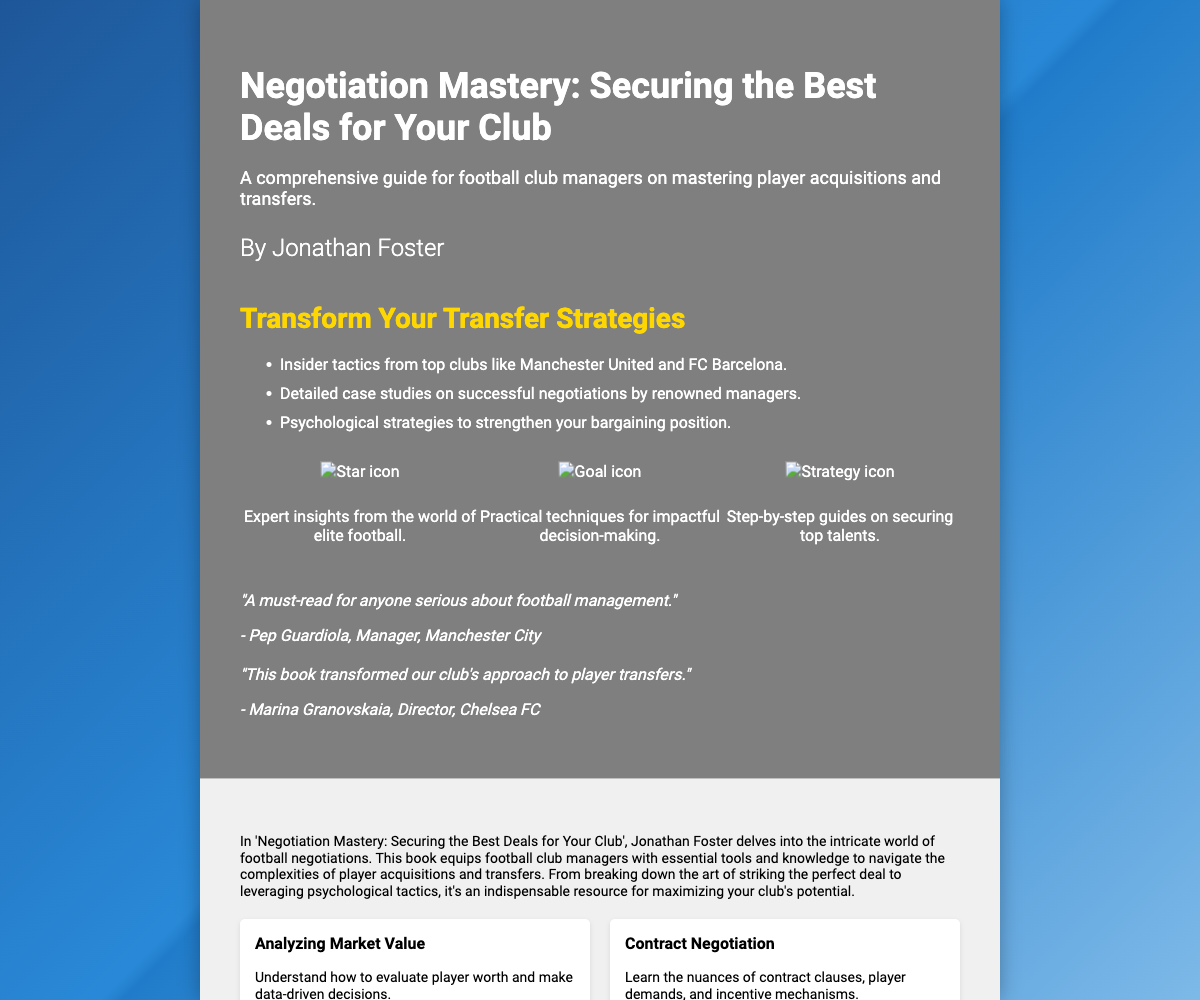What is the title of the book? The title of the book is prominently displayed at the top of the front cover.
Answer: Negotiation Mastery: Securing the Best Deals for Your Club Who is the author of the book? The author's name is mentioned below the title on the front cover.
Answer: Jonathan Foster What is the main focus of the book? The subtitle provides insight into the book's main theme regarding player acquisitions and transfers.
Answer: A comprehensive guide for football club managers on mastering player acquisitions and transfers Which renowned manager praised the book? A testimonial from a well-known football manager is included on the front cover.
Answer: Pep Guardiola How many key points are listed in the front cover section? The number of key points can be counted in the bullet list on the front cover.
Answer: Three What is one of the highlights mentioned in the back cover? Several highlights are provided in a grid format; one can be identified as part of the back cover content.
Answer: Analyzing Market Value How long has Jonathan Foster been involved in football management? The author bio mentions his years of experience in club management and player negotiations.
Answer: Over 20 years What is the color scheme of the book cover? The style and colors used in the design can be inferred from the background and text elements described.
Answer: Blue gradient How many testimonials are featured on the cover? The testimonials section includes evaluations from notable figures; the count can be determined from the content.
Answer: Two 